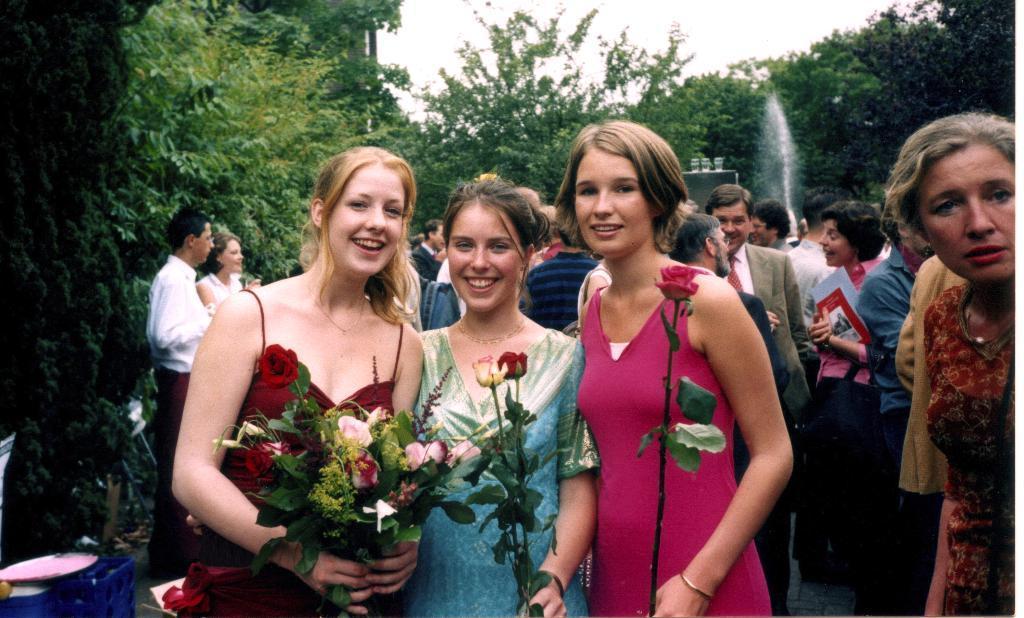Could you give a brief overview of what you see in this image? Here a beautiful girl is standing and smiling, she is holding rose flowers in her hands beside her other 2 girls are also standing behind them there are trees. 